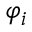<formula> <loc_0><loc_0><loc_500><loc_500>\varphi _ { i }</formula> 